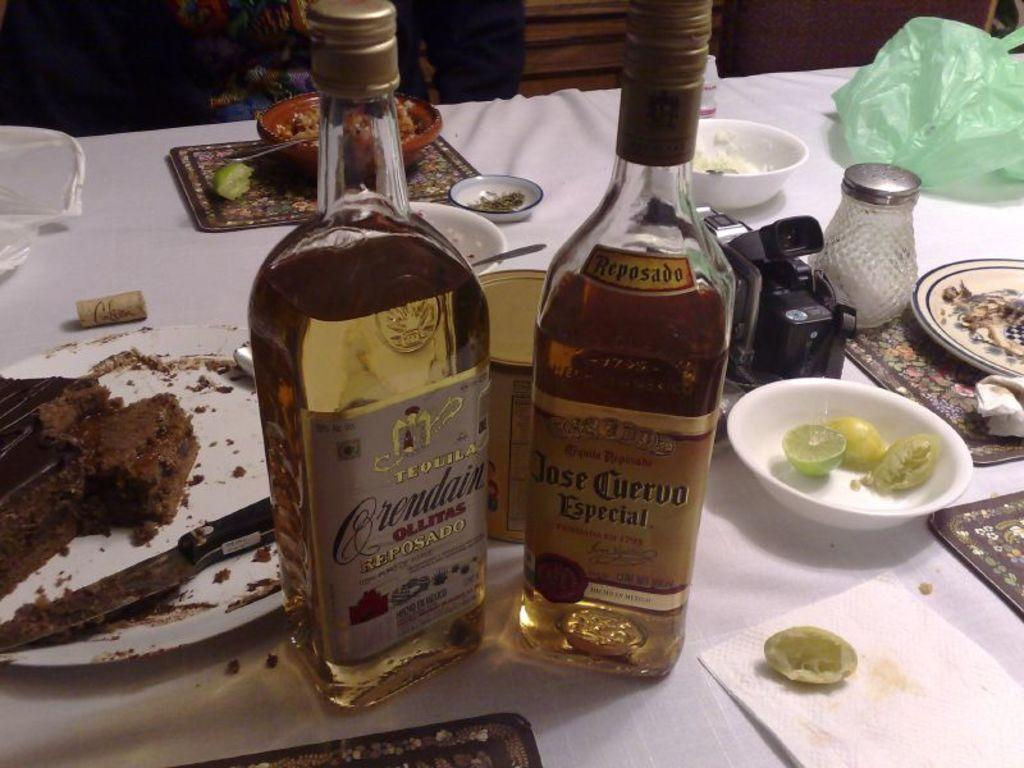Provide a one-sentence caption for the provided image. two bottles of liquor including Jose Cuervo on a table. 